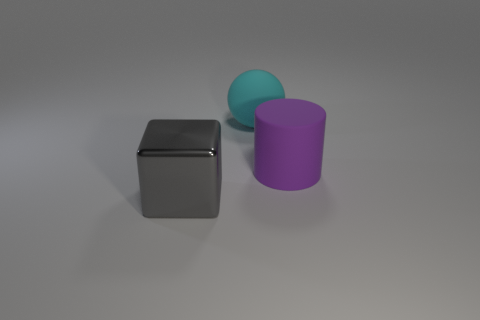Are there any other things that have the same material as the big cube?
Keep it short and to the point. No. Is there another large object that has the same color as the metal object?
Your answer should be compact. No. How many objects are objects behind the big metallic block or large gray metal blocks?
Your response must be concise. 3. How many other objects are there of the same size as the metal cube?
Give a very brief answer. 2. The big thing that is in front of the large rubber object to the right of the large matte object that is behind the purple object is made of what material?
Offer a very short reply. Metal. What number of blocks are either large gray shiny objects or big red rubber objects?
Provide a short and direct response. 1. Is there any other thing that has the same shape as the gray object?
Your response must be concise. No. Is the number of large balls that are on the left side of the cyan sphere greater than the number of objects that are in front of the large gray metallic block?
Make the answer very short. No. How many cyan rubber spheres are to the left of the object to the left of the cyan rubber object?
Give a very brief answer. 0. How many objects are rubber spheres or small yellow things?
Your response must be concise. 1. 